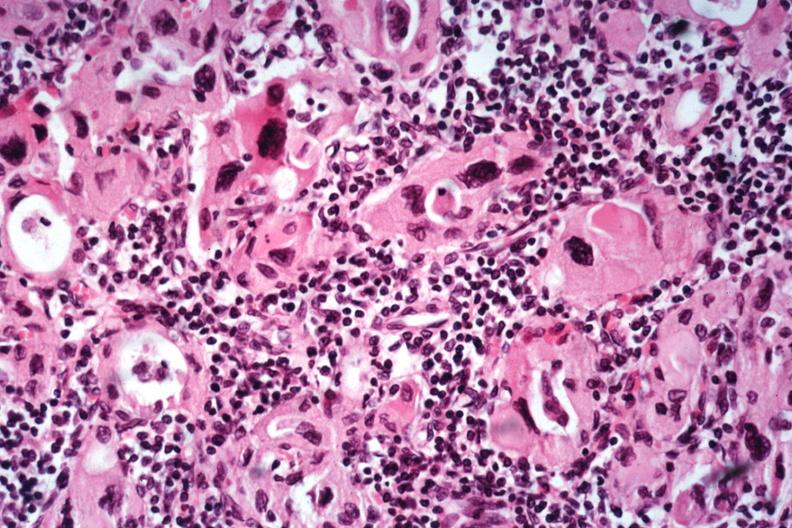what does this image show?
Answer the question using a single word or phrase. Excellent example lymphocytes and hurthle like cells no recognizable thyroid tissue 